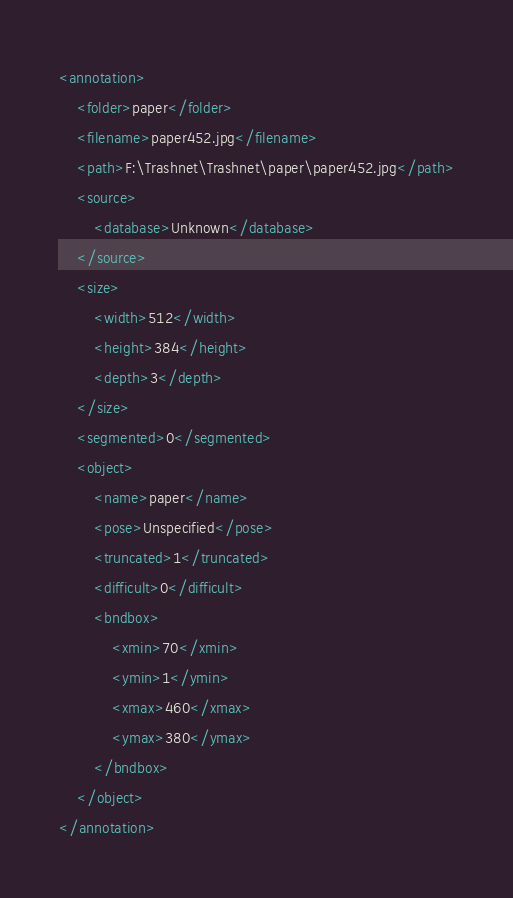Convert code to text. <code><loc_0><loc_0><loc_500><loc_500><_XML_><annotation>
	<folder>paper</folder>
	<filename>paper452.jpg</filename>
	<path>F:\Trashnet\Trashnet\paper\paper452.jpg</path>
	<source>
		<database>Unknown</database>
	</source>
	<size>
		<width>512</width>
		<height>384</height>
		<depth>3</depth>
	</size>
	<segmented>0</segmented>
	<object>
		<name>paper</name>
		<pose>Unspecified</pose>
		<truncated>1</truncated>
		<difficult>0</difficult>
		<bndbox>
			<xmin>70</xmin>
			<ymin>1</ymin>
			<xmax>460</xmax>
			<ymax>380</ymax>
		</bndbox>
	</object>
</annotation>
</code> 